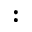<formula> <loc_0><loc_0><loc_500><loc_500>\colon</formula> 